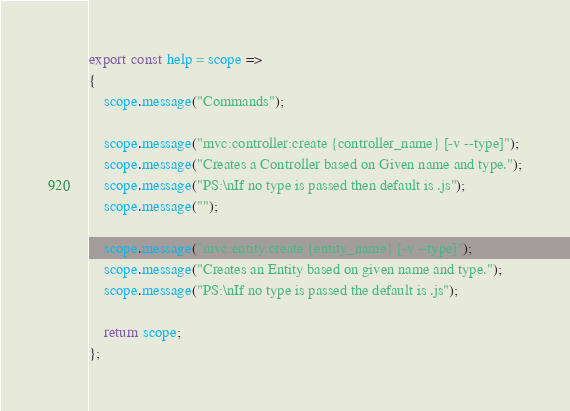Convert code to text. <code><loc_0><loc_0><loc_500><loc_500><_JavaScript_>export const help = scope => 
{
    scope.message("Commands");

    scope.message("mvc:controller:create {controller_name} [-v --type]");
    scope.message("Creates a Controller based on Given name and type.");
    scope.message("PS:\nIf no type is passed then default is .js");
    scope.message("");

    scope.message("mvc:entity:create {entity_name} [-v --type]");
    scope.message("Creates an Entity based on given name and type.");
    scope.message("PS:\nIf no type is passed the default is .js");

    return scope;
};
</code> 